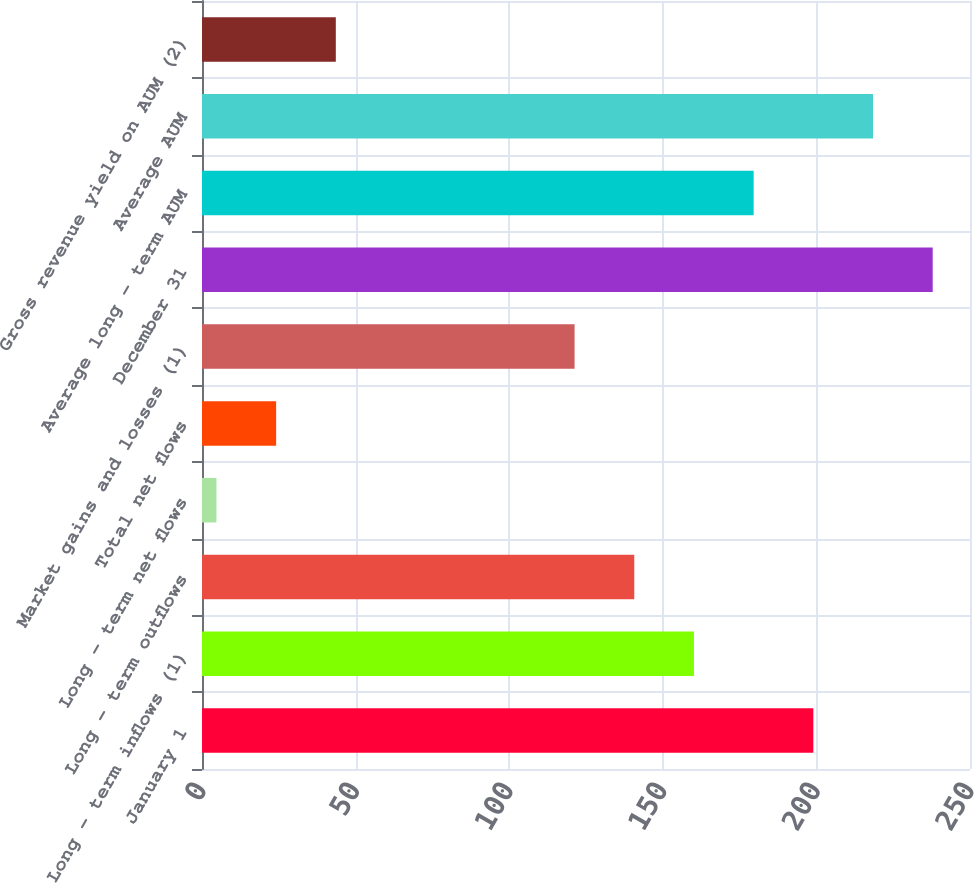Convert chart to OTSL. <chart><loc_0><loc_0><loc_500><loc_500><bar_chart><fcel>January 1<fcel>Long - term inflows (1)<fcel>Long - term outflows<fcel>Long - term net flows<fcel>Total net flows<fcel>Market gains and losses (1)<fcel>December 31<fcel>Average long - term AUM<fcel>Average AUM<fcel>Gross revenue yield on AUM (2)<nl><fcel>199<fcel>160.14<fcel>140.71<fcel>4.7<fcel>24.13<fcel>121.28<fcel>237.86<fcel>179.57<fcel>218.43<fcel>43.56<nl></chart> 